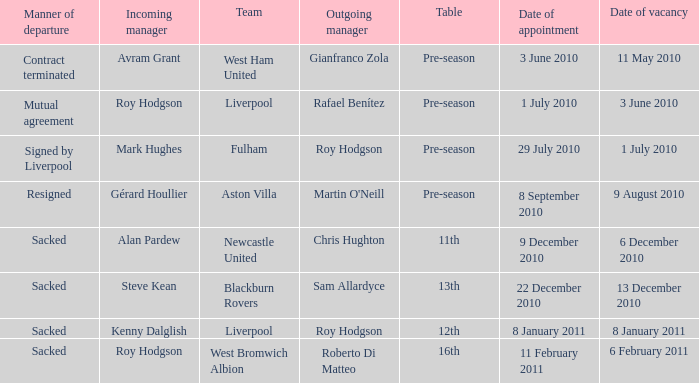What was the date of appointment for incoming manager Roy Hodgson and the team is Liverpool? 1 July 2010. 